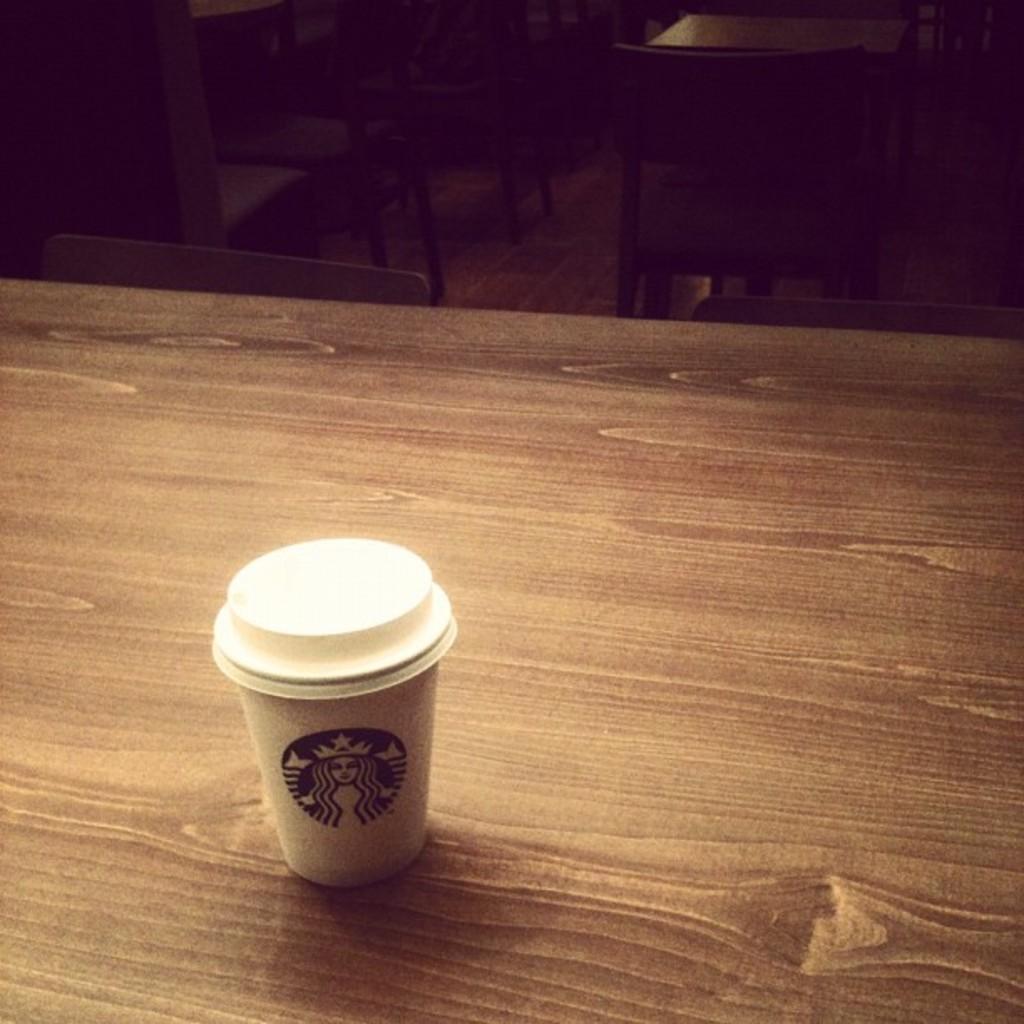How would you summarize this image in a sentence or two? In this image at the bottom there is a table, on the table there is one cup and in the background there are some chairs. 